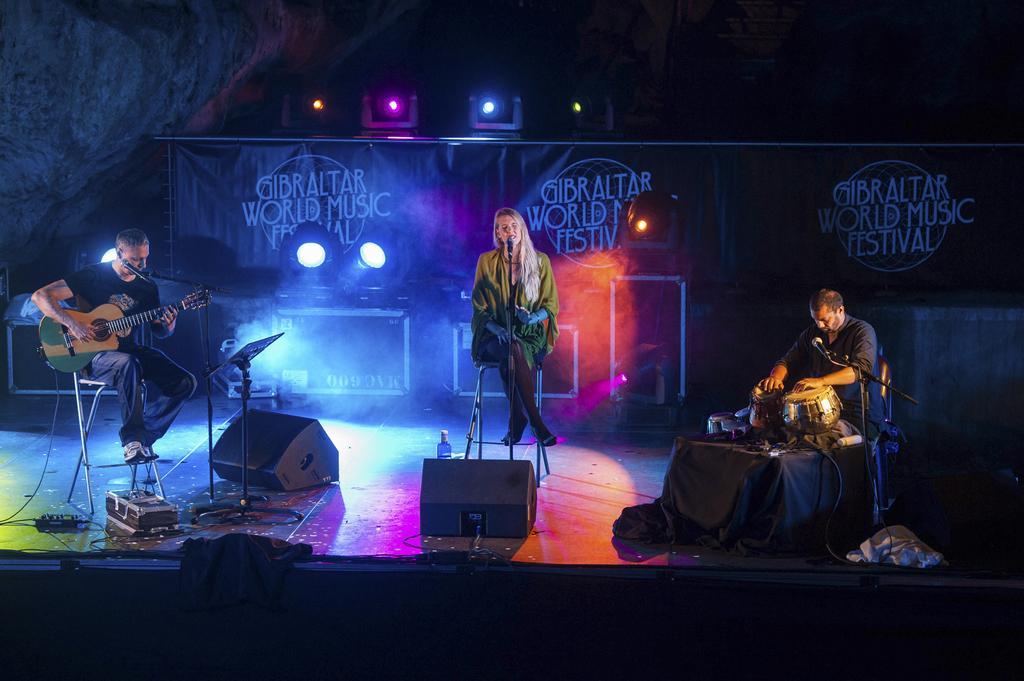Describe this image in one or two sentences. Here is a stage a woman is sitting on the chair and singing a song and the left side of an image a person sitting on the chair and playing the guitar. Here is a microphone behind him there are disco lights and banner the right side of an image person sitting on the chair and playing drums. 